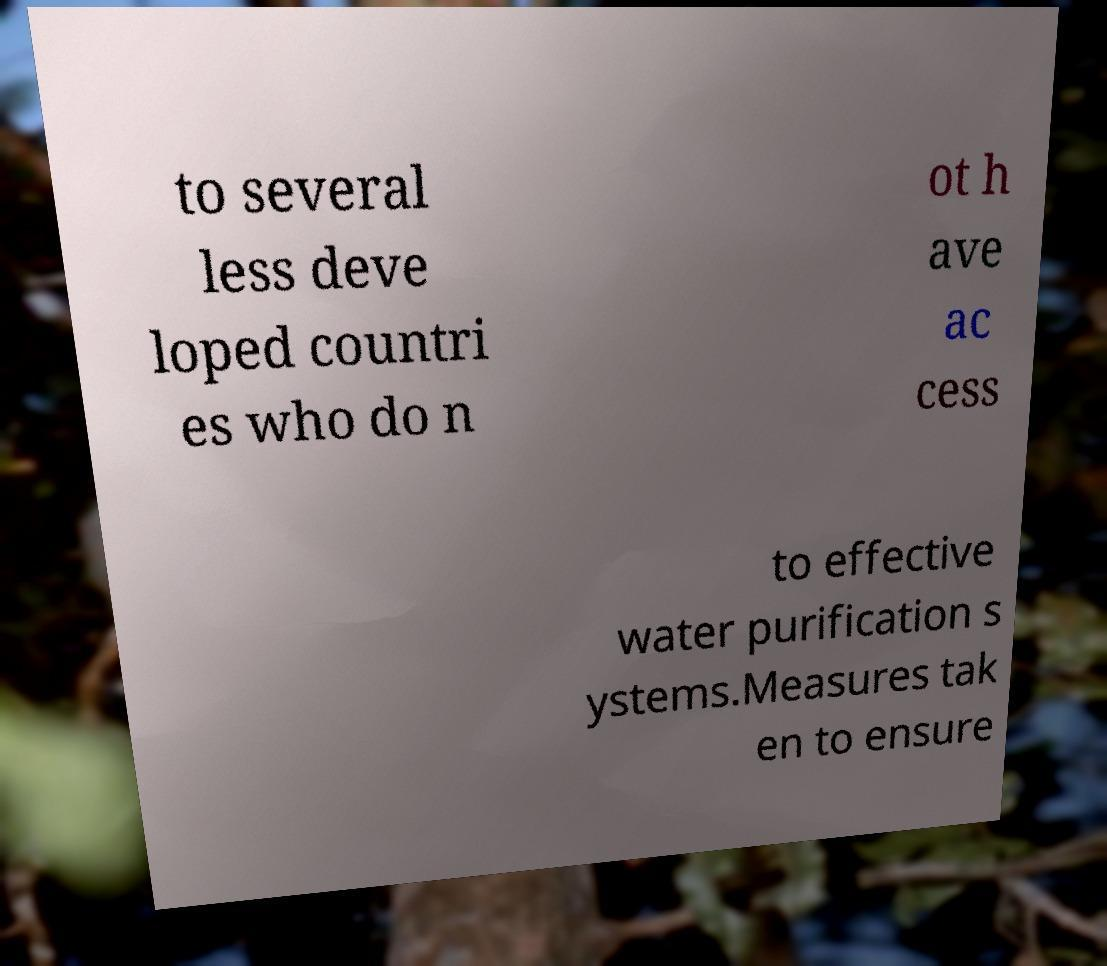There's text embedded in this image that I need extracted. Can you transcribe it verbatim? to several less deve loped countri es who do n ot h ave ac cess to effective water purification s ystems.Measures tak en to ensure 